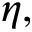<formula> <loc_0><loc_0><loc_500><loc_500>\eta ,</formula> 